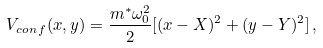Convert formula to latex. <formula><loc_0><loc_0><loc_500><loc_500>V _ { c o n \, f } ( x , y ) = \frac { m ^ { * } \omega _ { 0 } ^ { 2 } } { 2 } [ ( x - X ) ^ { 2 } + ( y - Y ) ^ { 2 } ] \, ,</formula> 